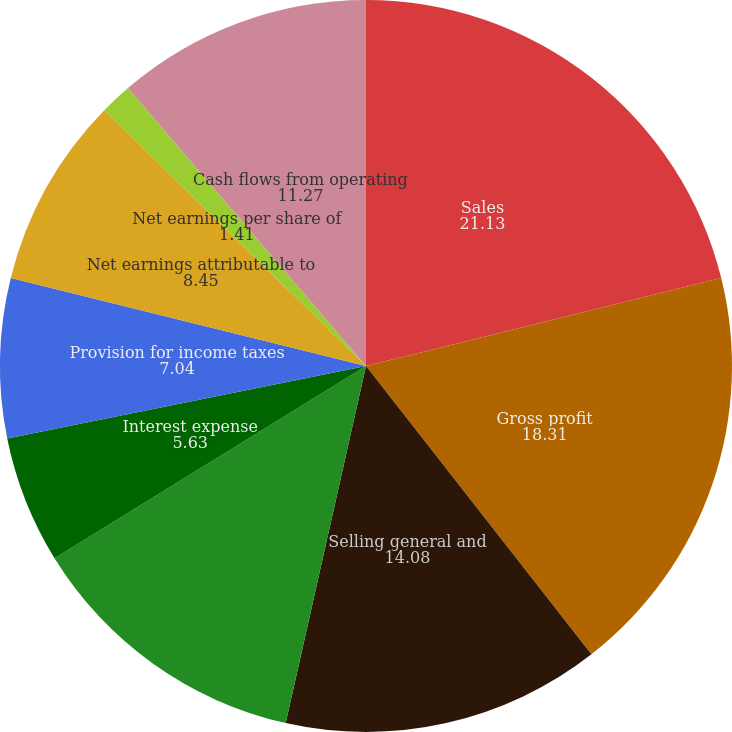<chart> <loc_0><loc_0><loc_500><loc_500><pie_chart><fcel>Sales<fcel>Gross profit<fcel>Selling general and<fcel>Operating income<fcel>Interest expense<fcel>Provision for income taxes<fcel>Net earnings attributable to<fcel>Net earnings per share of<fcel>Cash flows from operating<fcel>Cash dividends declared per<nl><fcel>21.13%<fcel>18.31%<fcel>14.08%<fcel>12.68%<fcel>5.63%<fcel>7.04%<fcel>8.45%<fcel>1.41%<fcel>11.27%<fcel>0.0%<nl></chart> 